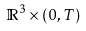Convert formula to latex. <formula><loc_0><loc_0><loc_500><loc_500>\mathbb { R } ^ { 3 } \times ( 0 , T )</formula> 